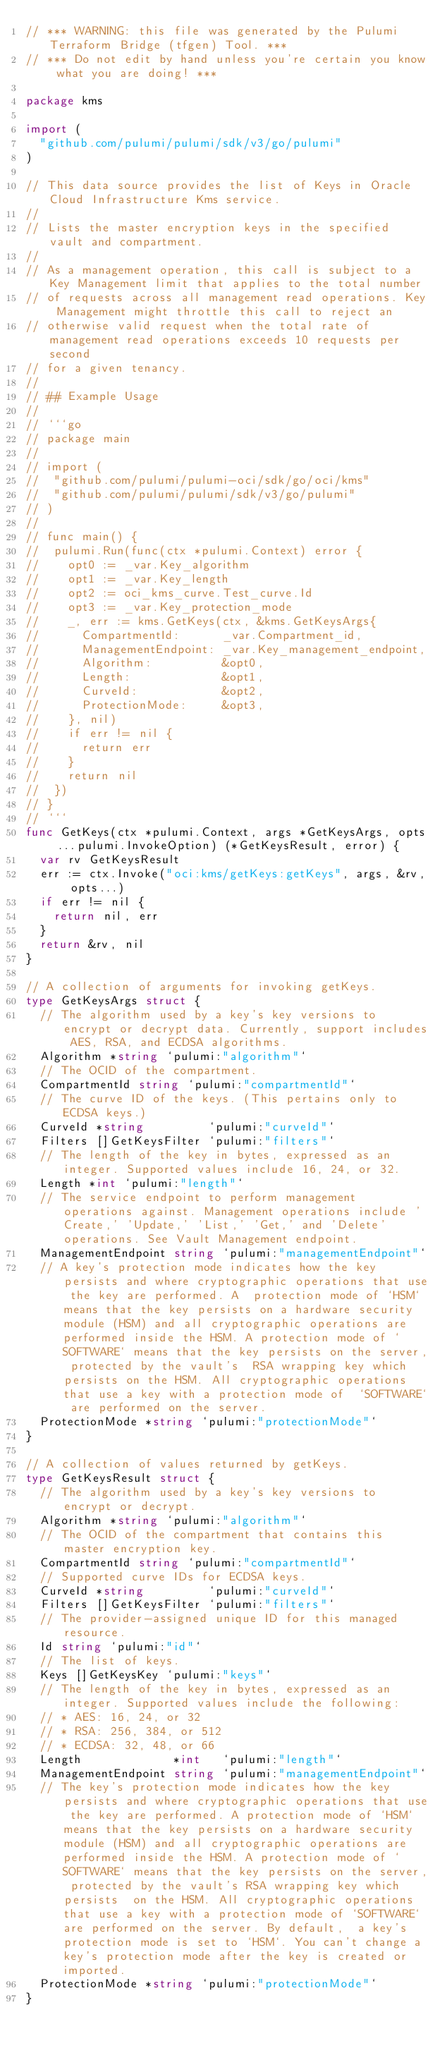<code> <loc_0><loc_0><loc_500><loc_500><_Go_>// *** WARNING: this file was generated by the Pulumi Terraform Bridge (tfgen) Tool. ***
// *** Do not edit by hand unless you're certain you know what you are doing! ***

package kms

import (
	"github.com/pulumi/pulumi/sdk/v3/go/pulumi"
)

// This data source provides the list of Keys in Oracle Cloud Infrastructure Kms service.
//
// Lists the master encryption keys in the specified vault and compartment.
//
// As a management operation, this call is subject to a Key Management limit that applies to the total number
// of requests across all management read operations. Key Management might throttle this call to reject an
// otherwise valid request when the total rate of management read operations exceeds 10 requests per second
// for a given tenancy.
//
// ## Example Usage
//
// ```go
// package main
//
// import (
// 	"github.com/pulumi/pulumi-oci/sdk/go/oci/kms"
// 	"github.com/pulumi/pulumi/sdk/v3/go/pulumi"
// )
//
// func main() {
// 	pulumi.Run(func(ctx *pulumi.Context) error {
// 		opt0 := _var.Key_algorithm
// 		opt1 := _var.Key_length
// 		opt2 := oci_kms_curve.Test_curve.Id
// 		opt3 := _var.Key_protection_mode
// 		_, err := kms.GetKeys(ctx, &kms.GetKeysArgs{
// 			CompartmentId:      _var.Compartment_id,
// 			ManagementEndpoint: _var.Key_management_endpoint,
// 			Algorithm:          &opt0,
// 			Length:             &opt1,
// 			CurveId:            &opt2,
// 			ProtectionMode:     &opt3,
// 		}, nil)
// 		if err != nil {
// 			return err
// 		}
// 		return nil
// 	})
// }
// ```
func GetKeys(ctx *pulumi.Context, args *GetKeysArgs, opts ...pulumi.InvokeOption) (*GetKeysResult, error) {
	var rv GetKeysResult
	err := ctx.Invoke("oci:kms/getKeys:getKeys", args, &rv, opts...)
	if err != nil {
		return nil, err
	}
	return &rv, nil
}

// A collection of arguments for invoking getKeys.
type GetKeysArgs struct {
	// The algorithm used by a key's key versions to encrypt or decrypt data. Currently, support includes AES, RSA, and ECDSA algorithms.
	Algorithm *string `pulumi:"algorithm"`
	// The OCID of the compartment.
	CompartmentId string `pulumi:"compartmentId"`
	// The curve ID of the keys. (This pertains only to ECDSA keys.)
	CurveId *string         `pulumi:"curveId"`
	Filters []GetKeysFilter `pulumi:"filters"`
	// The length of the key in bytes, expressed as an integer. Supported values include 16, 24, or 32.
	Length *int `pulumi:"length"`
	// The service endpoint to perform management operations against. Management operations include 'Create,' 'Update,' 'List,' 'Get,' and 'Delete' operations. See Vault Management endpoint.
	ManagementEndpoint string `pulumi:"managementEndpoint"`
	// A key's protection mode indicates how the key persists and where cryptographic operations that use the key are performed. A  protection mode of `HSM` means that the key persists on a hardware security module (HSM) and all cryptographic operations are  performed inside the HSM. A protection mode of `SOFTWARE` means that the key persists on the server, protected by the vault's  RSA wrapping key which persists on the HSM. All cryptographic operations that use a key with a protection mode of  `SOFTWARE` are performed on the server.
	ProtectionMode *string `pulumi:"protectionMode"`
}

// A collection of values returned by getKeys.
type GetKeysResult struct {
	// The algorithm used by a key's key versions to encrypt or decrypt.
	Algorithm *string `pulumi:"algorithm"`
	// The OCID of the compartment that contains this master encryption key.
	CompartmentId string `pulumi:"compartmentId"`
	// Supported curve IDs for ECDSA keys.
	CurveId *string         `pulumi:"curveId"`
	Filters []GetKeysFilter `pulumi:"filters"`
	// The provider-assigned unique ID for this managed resource.
	Id string `pulumi:"id"`
	// The list of keys.
	Keys []GetKeysKey `pulumi:"keys"`
	// The length of the key in bytes, expressed as an integer. Supported values include the following:
	// * AES: 16, 24, or 32
	// * RSA: 256, 384, or 512
	// * ECDSA: 32, 48, or 66
	Length             *int   `pulumi:"length"`
	ManagementEndpoint string `pulumi:"managementEndpoint"`
	// The key's protection mode indicates how the key persists and where cryptographic operations that use the key are performed. A protection mode of `HSM` means that the key persists on a hardware security module (HSM) and all cryptographic operations are performed inside the HSM. A protection mode of `SOFTWARE` means that the key persists on the server, protected by the vault's RSA wrapping key which persists  on the HSM. All cryptographic operations that use a key with a protection mode of `SOFTWARE` are performed on the server. By default,  a key's protection mode is set to `HSM`. You can't change a key's protection mode after the key is created or imported.
	ProtectionMode *string `pulumi:"protectionMode"`
}
</code> 